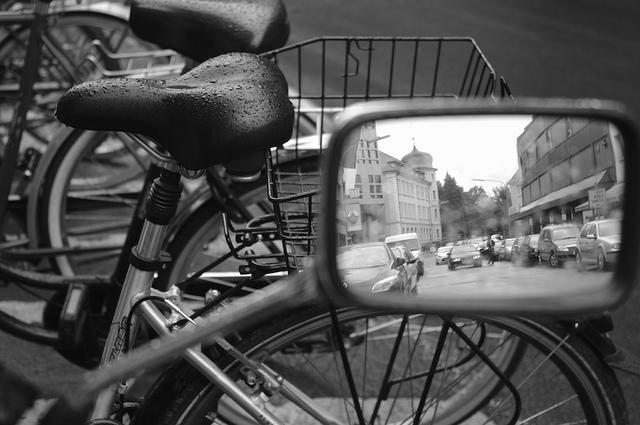Why is the black bike seat wet?

Choices:
A) perspiration
B) sea mist
C) spill
D) rain rain 